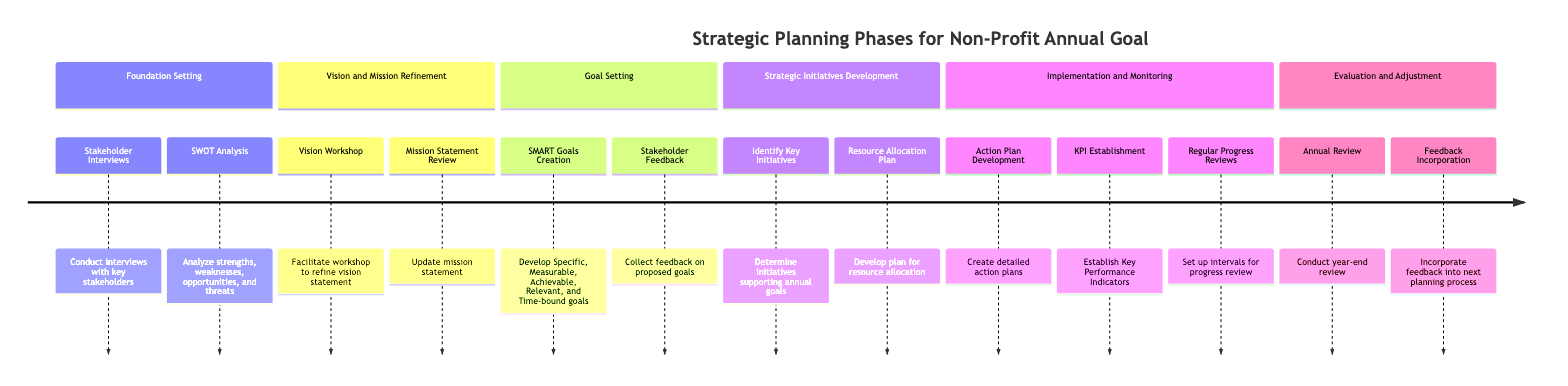What are the first two steps in the Foundation Setting phase? The diagram shows that the first two steps listed under the Foundation Setting phase are "Stakeholder Interviews" and "SWOT Analysis."
Answer: Stakeholder Interviews, SWOT Analysis How many phases are in the timeline? The diagram illustrates a total of 6 distinct phases: Foundation Setting, Vision and Mission Refinement, Goal Setting, Strategic Initiatives Development, Implementation and Monitoring, and Evaluation and Adjustment.
Answer: 6 What is the last step in the Evaluation and Adjustment phase? According to the diagram, the last step listed in the Evaluation and Adjustment phase is "Feedback Incorporation."
Answer: Feedback Incorporation In which phase does "Resource Allocation Plan" occur? By examining the timeline, "Resource Allocation Plan" is identified as a step in the "Strategic Initiatives Development" phase.
Answer: Strategic Initiatives Development What step involves collecting feedback from stakeholders? The diagram highlights that the step focusing on collecting feedback from stakeholders is "Stakeholder Feedback," which is found in the Goal Setting phase.
Answer: Stakeholder Feedback What is developed in the Implementation and Monitoring phase to track progress? The diagram specifies that "KPI Establishment" is created in the Implementation and Monitoring phase to track the progress of strategic initiatives.
Answer: KPI Establishment How many steps are in the Strategic Initiatives Development phase? The timeline clearly lays out 2 steps in the Strategic Initiatives Development phase: "Identify Key Initiatives" and "Resource Allocation Plan."
Answer: 2 What type of goals are created in the Goal Setting phase? The diagram indicates that "SMART Goals Creation" is the focus in the Goal Setting phase, which specifies that goals should be specific, measurable, achievable, relevant, and time-bound.
Answer: SMART Goals Which phase includes the "Vision Workshop"? The "Vision Workshop" is explicitly listed under the "Vision and Mission Refinement" phase in the diagram.
Answer: Vision and Mission Refinement 